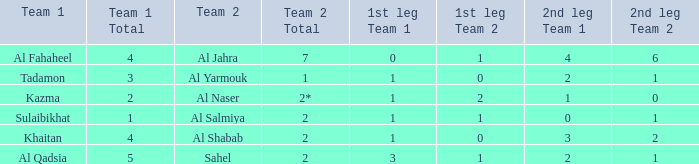What is the name of Team 2 with a Team 1 of Al Qadsia? Sahel. 